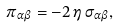<formula> <loc_0><loc_0><loc_500><loc_500>\pi _ { \alpha \beta } = - 2 \, \eta \, \sigma _ { \alpha \beta } ,</formula> 